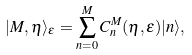<formula> <loc_0><loc_0><loc_500><loc_500>| M , \eta \rangle _ { \epsilon } = \sum _ { n = 0 } ^ { M } C _ { n } ^ { M } ( \eta , \epsilon ) | n \rangle ,</formula> 